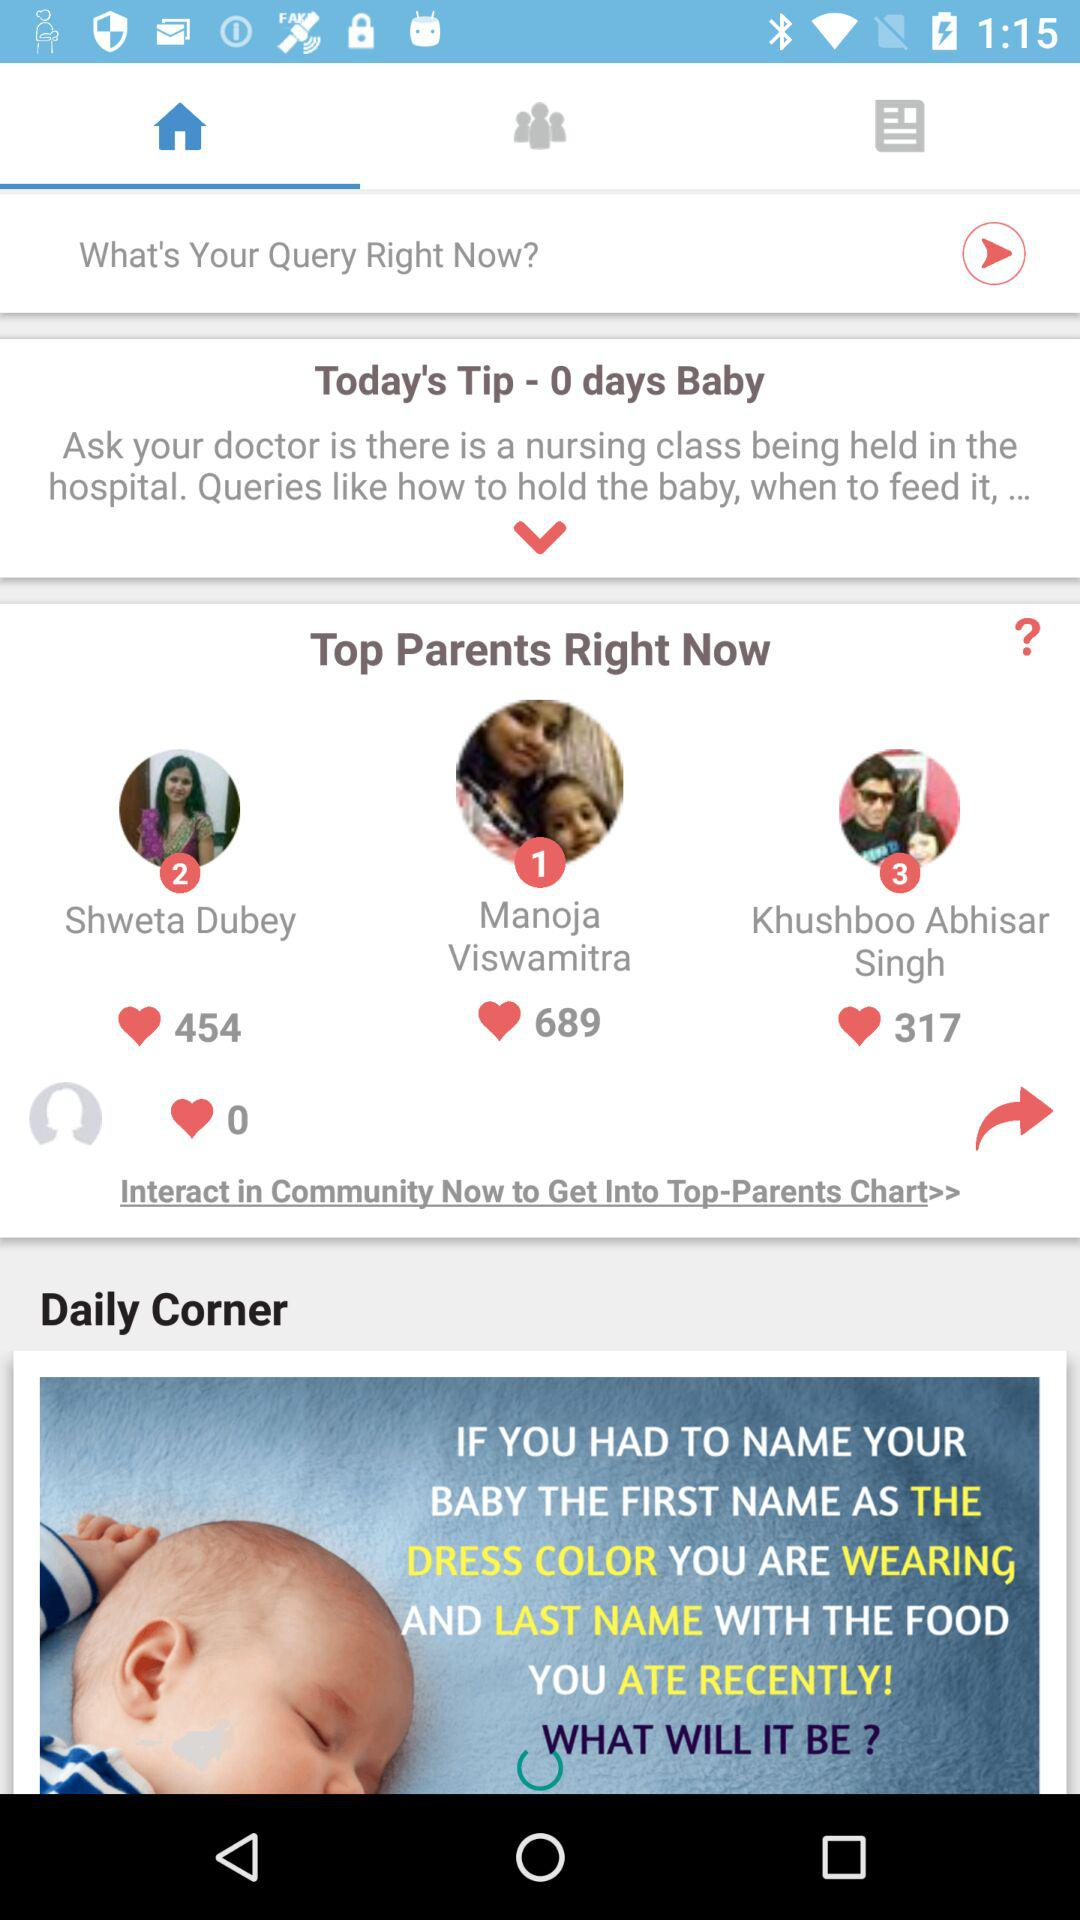What is the rank of Shweta Dubey in the "Top Parents"? The rank of Shweta Dubey is 2. 